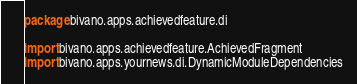Convert code to text. <code><loc_0><loc_0><loc_500><loc_500><_Kotlin_>package bivano.apps.achievedfeature.di

import bivano.apps.achievedfeature.AchievedFragment
import bivano.apps.yournews.di.DynamicModuleDependencies</code> 